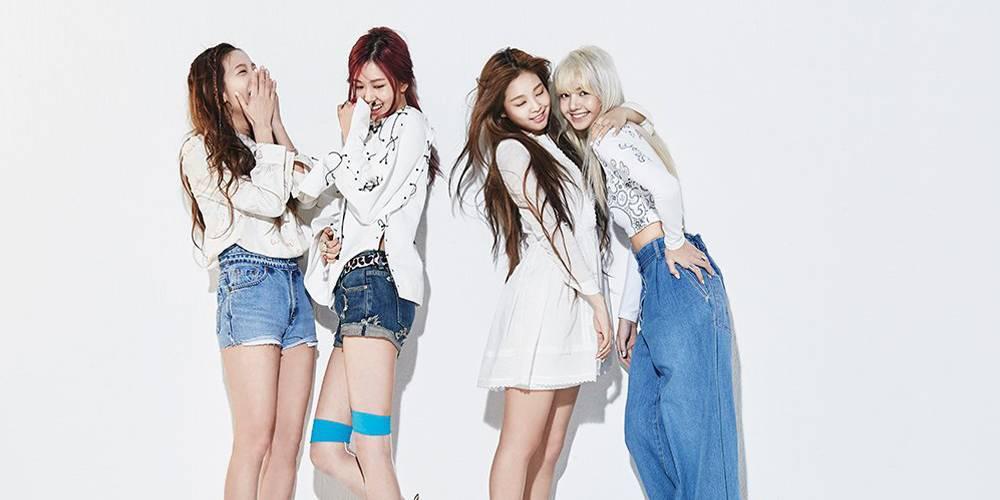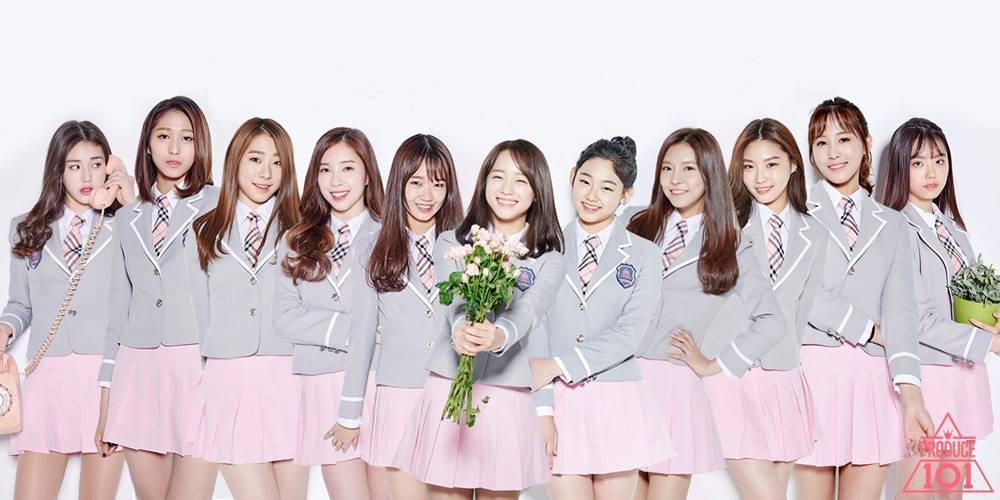The first image is the image on the left, the second image is the image on the right. Examine the images to the left and right. Is the description "There are more than four women in total." accurate? Answer yes or no. Yes. 